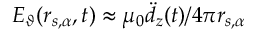Convert formula to latex. <formula><loc_0><loc_0><loc_500><loc_500>E _ { \vartheta } ( r _ { s , \alpha } , t ) \approx \mu _ { 0 } \ddot { d } _ { z } ( t ) / 4 \pi r _ { s , \alpha }</formula> 